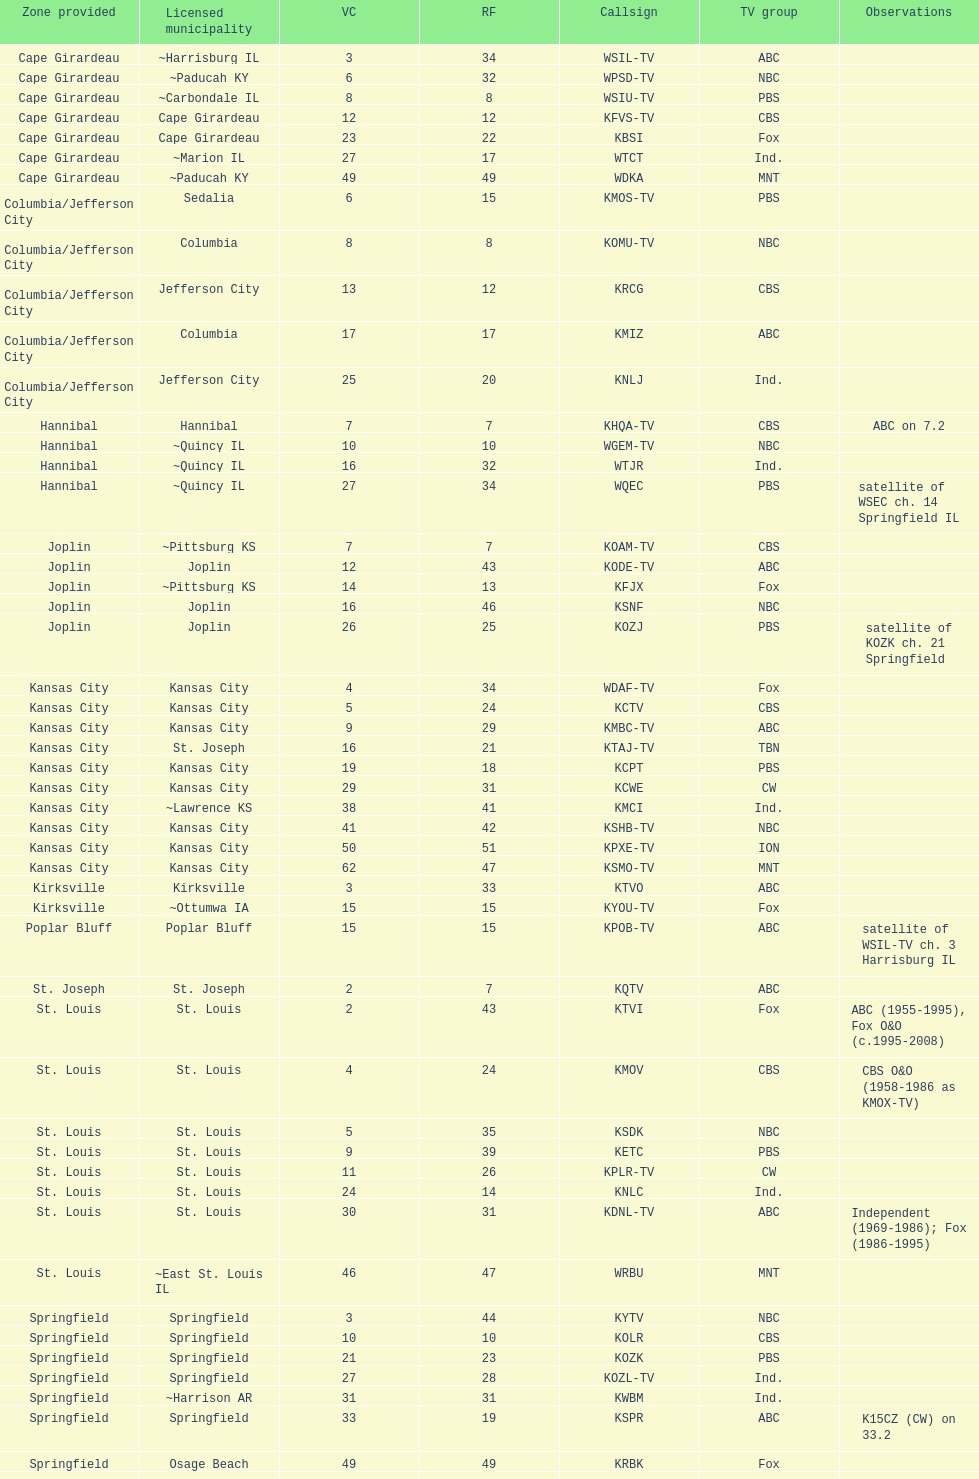What is the total number of stations under the cbs network? 7. 